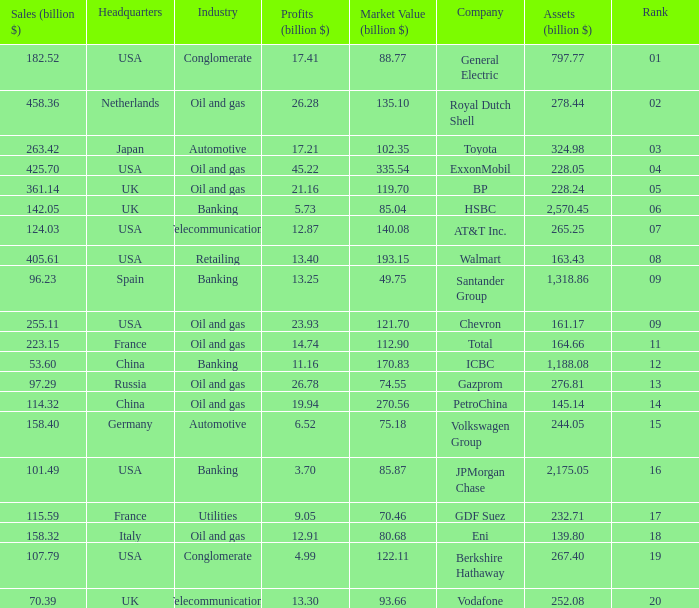Name the Sales (billion $) which have a Company of exxonmobil? 425.7. 